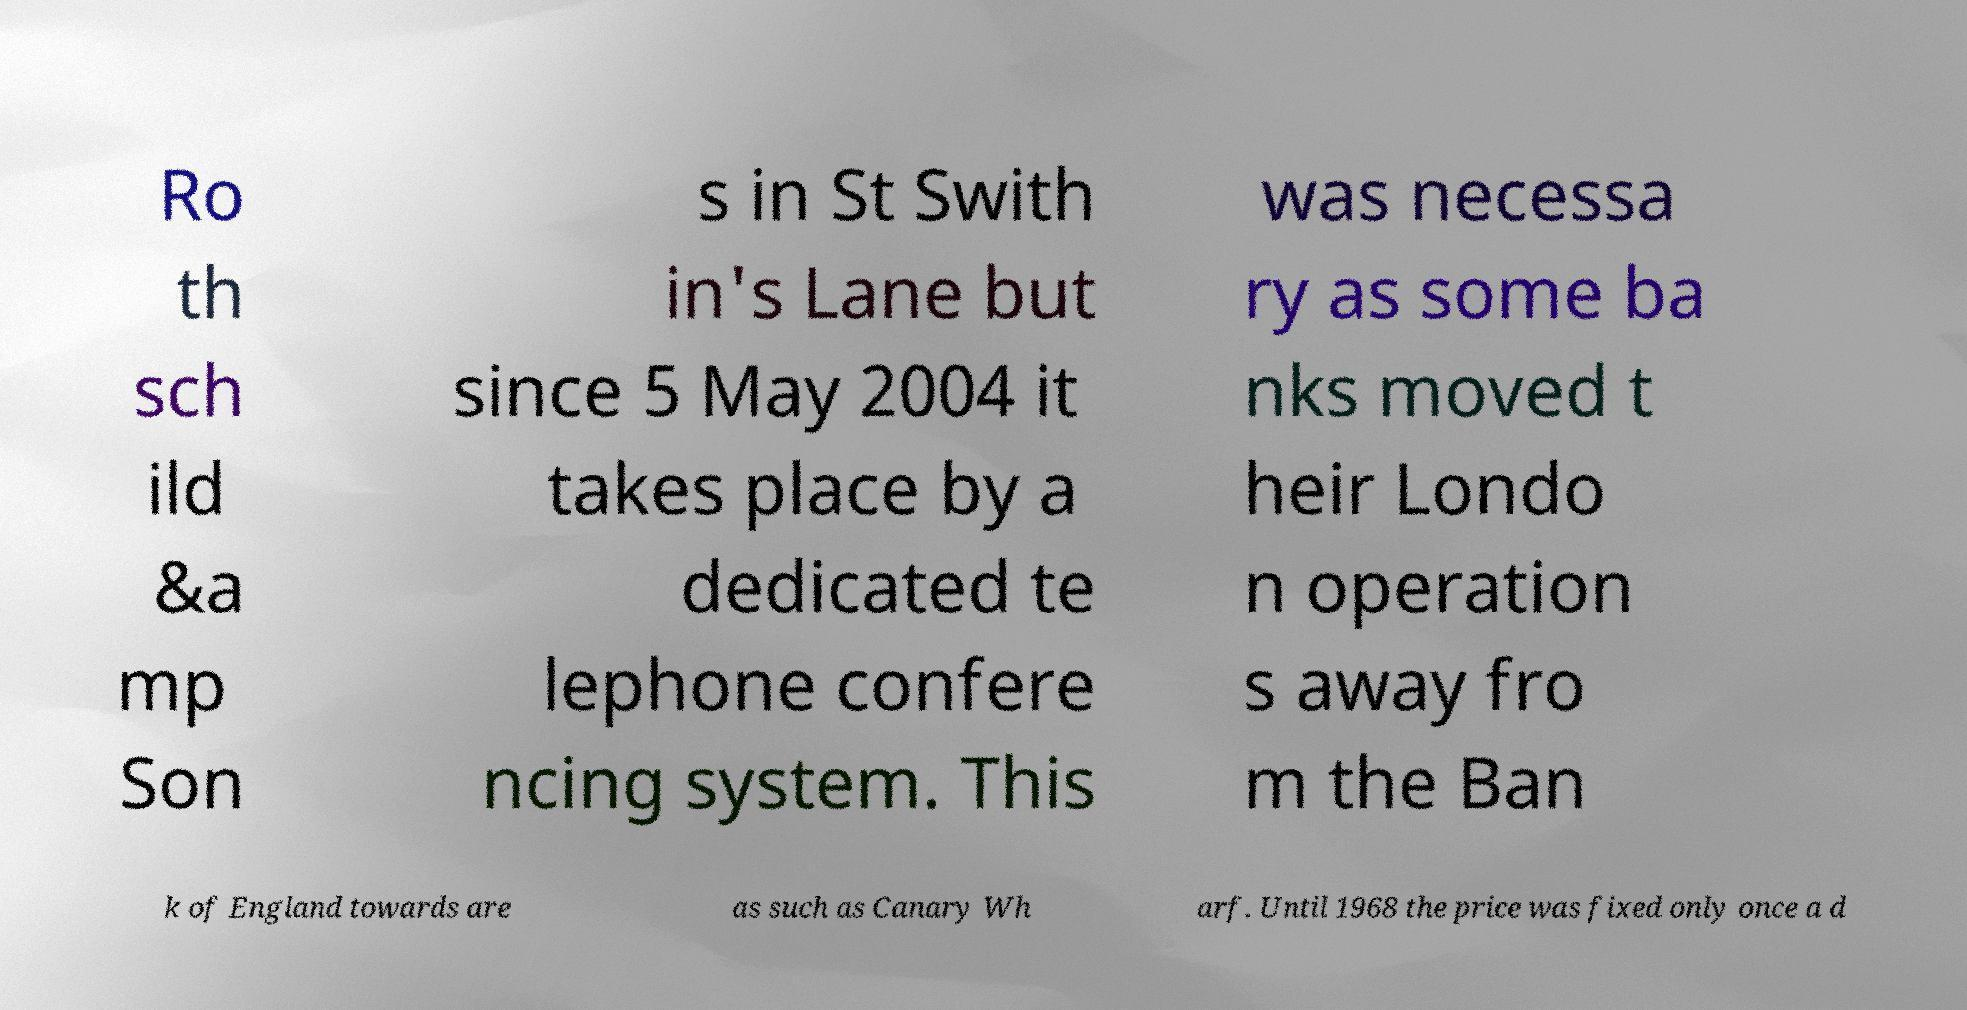Could you assist in decoding the text presented in this image and type it out clearly? Ro th sch ild &a mp Son s in St Swith in's Lane but since 5 May 2004 it takes place by a dedicated te lephone confere ncing system. This was necessa ry as some ba nks moved t heir Londo n operation s away fro m the Ban k of England towards are as such as Canary Wh arf. Until 1968 the price was fixed only once a d 